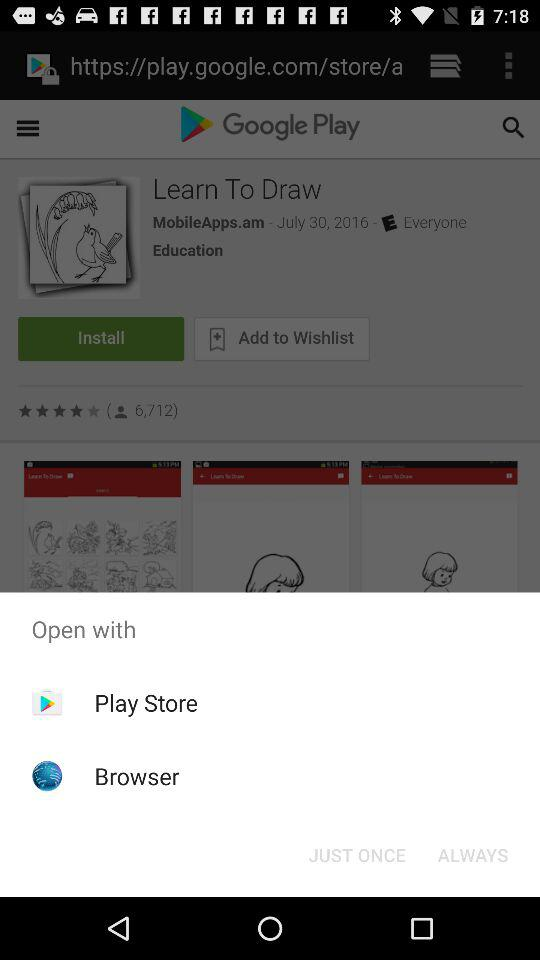What is the given rating? The given rating is "4 stars". 